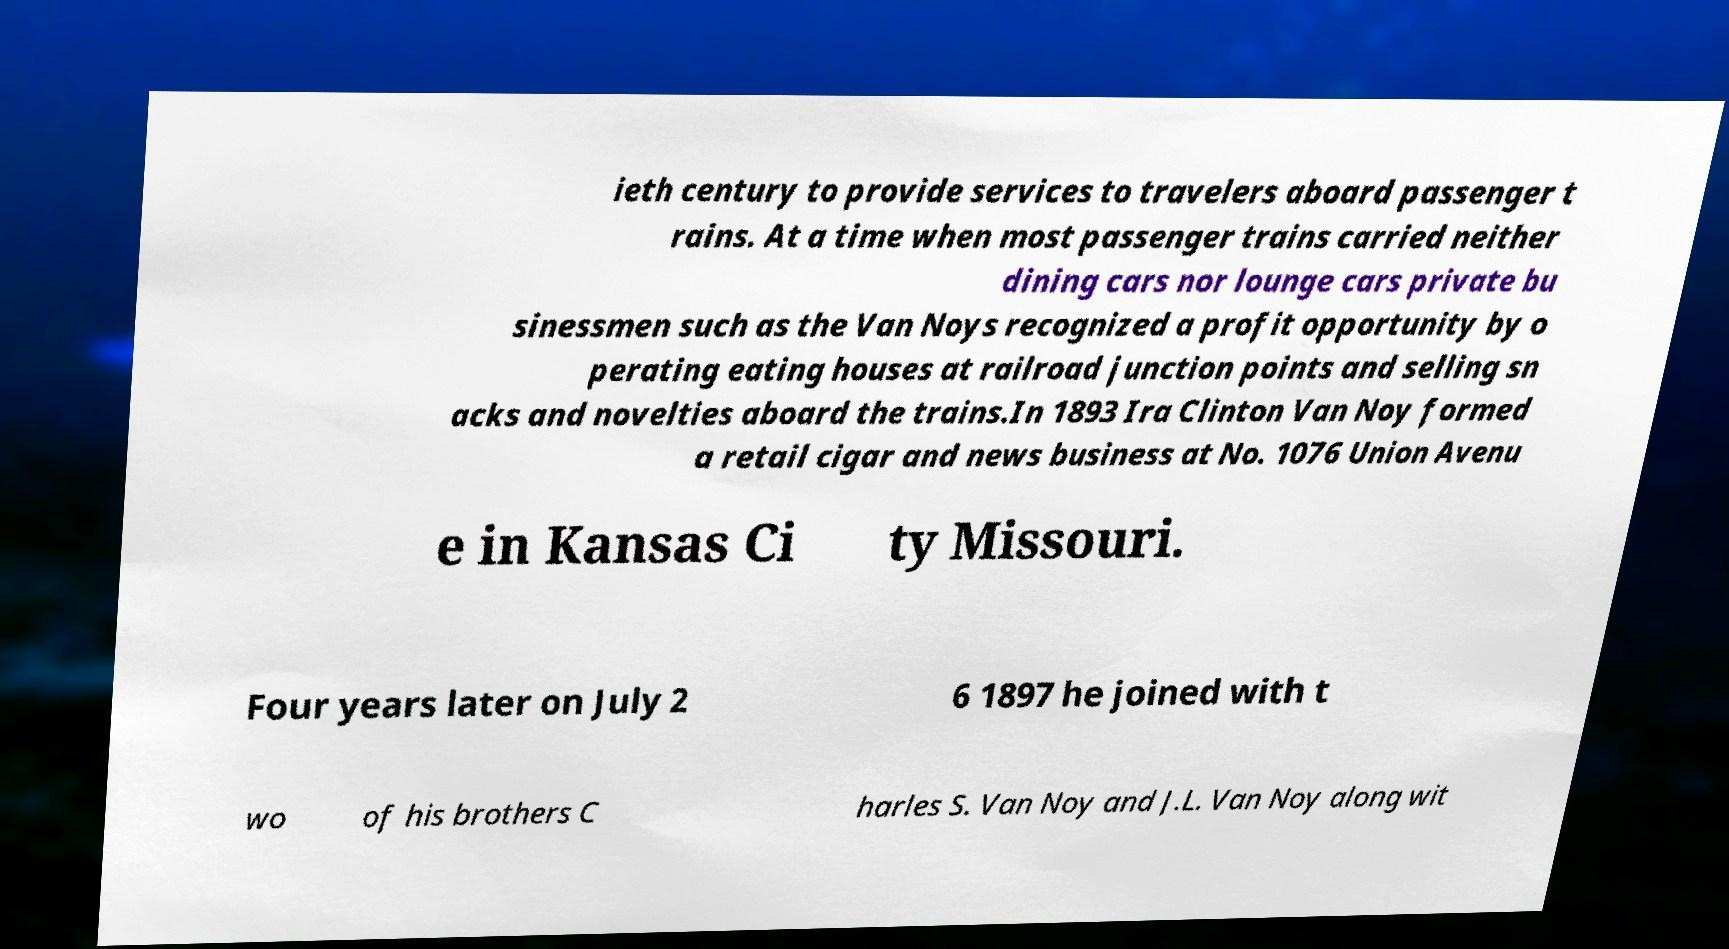Can you read and provide the text displayed in the image?This photo seems to have some interesting text. Can you extract and type it out for me? ieth century to provide services to travelers aboard passenger t rains. At a time when most passenger trains carried neither dining cars nor lounge cars private bu sinessmen such as the Van Noys recognized a profit opportunity by o perating eating houses at railroad junction points and selling sn acks and novelties aboard the trains.In 1893 Ira Clinton Van Noy formed a retail cigar and news business at No. 1076 Union Avenu e in Kansas Ci ty Missouri. Four years later on July 2 6 1897 he joined with t wo of his brothers C harles S. Van Noy and J.L. Van Noy along wit 